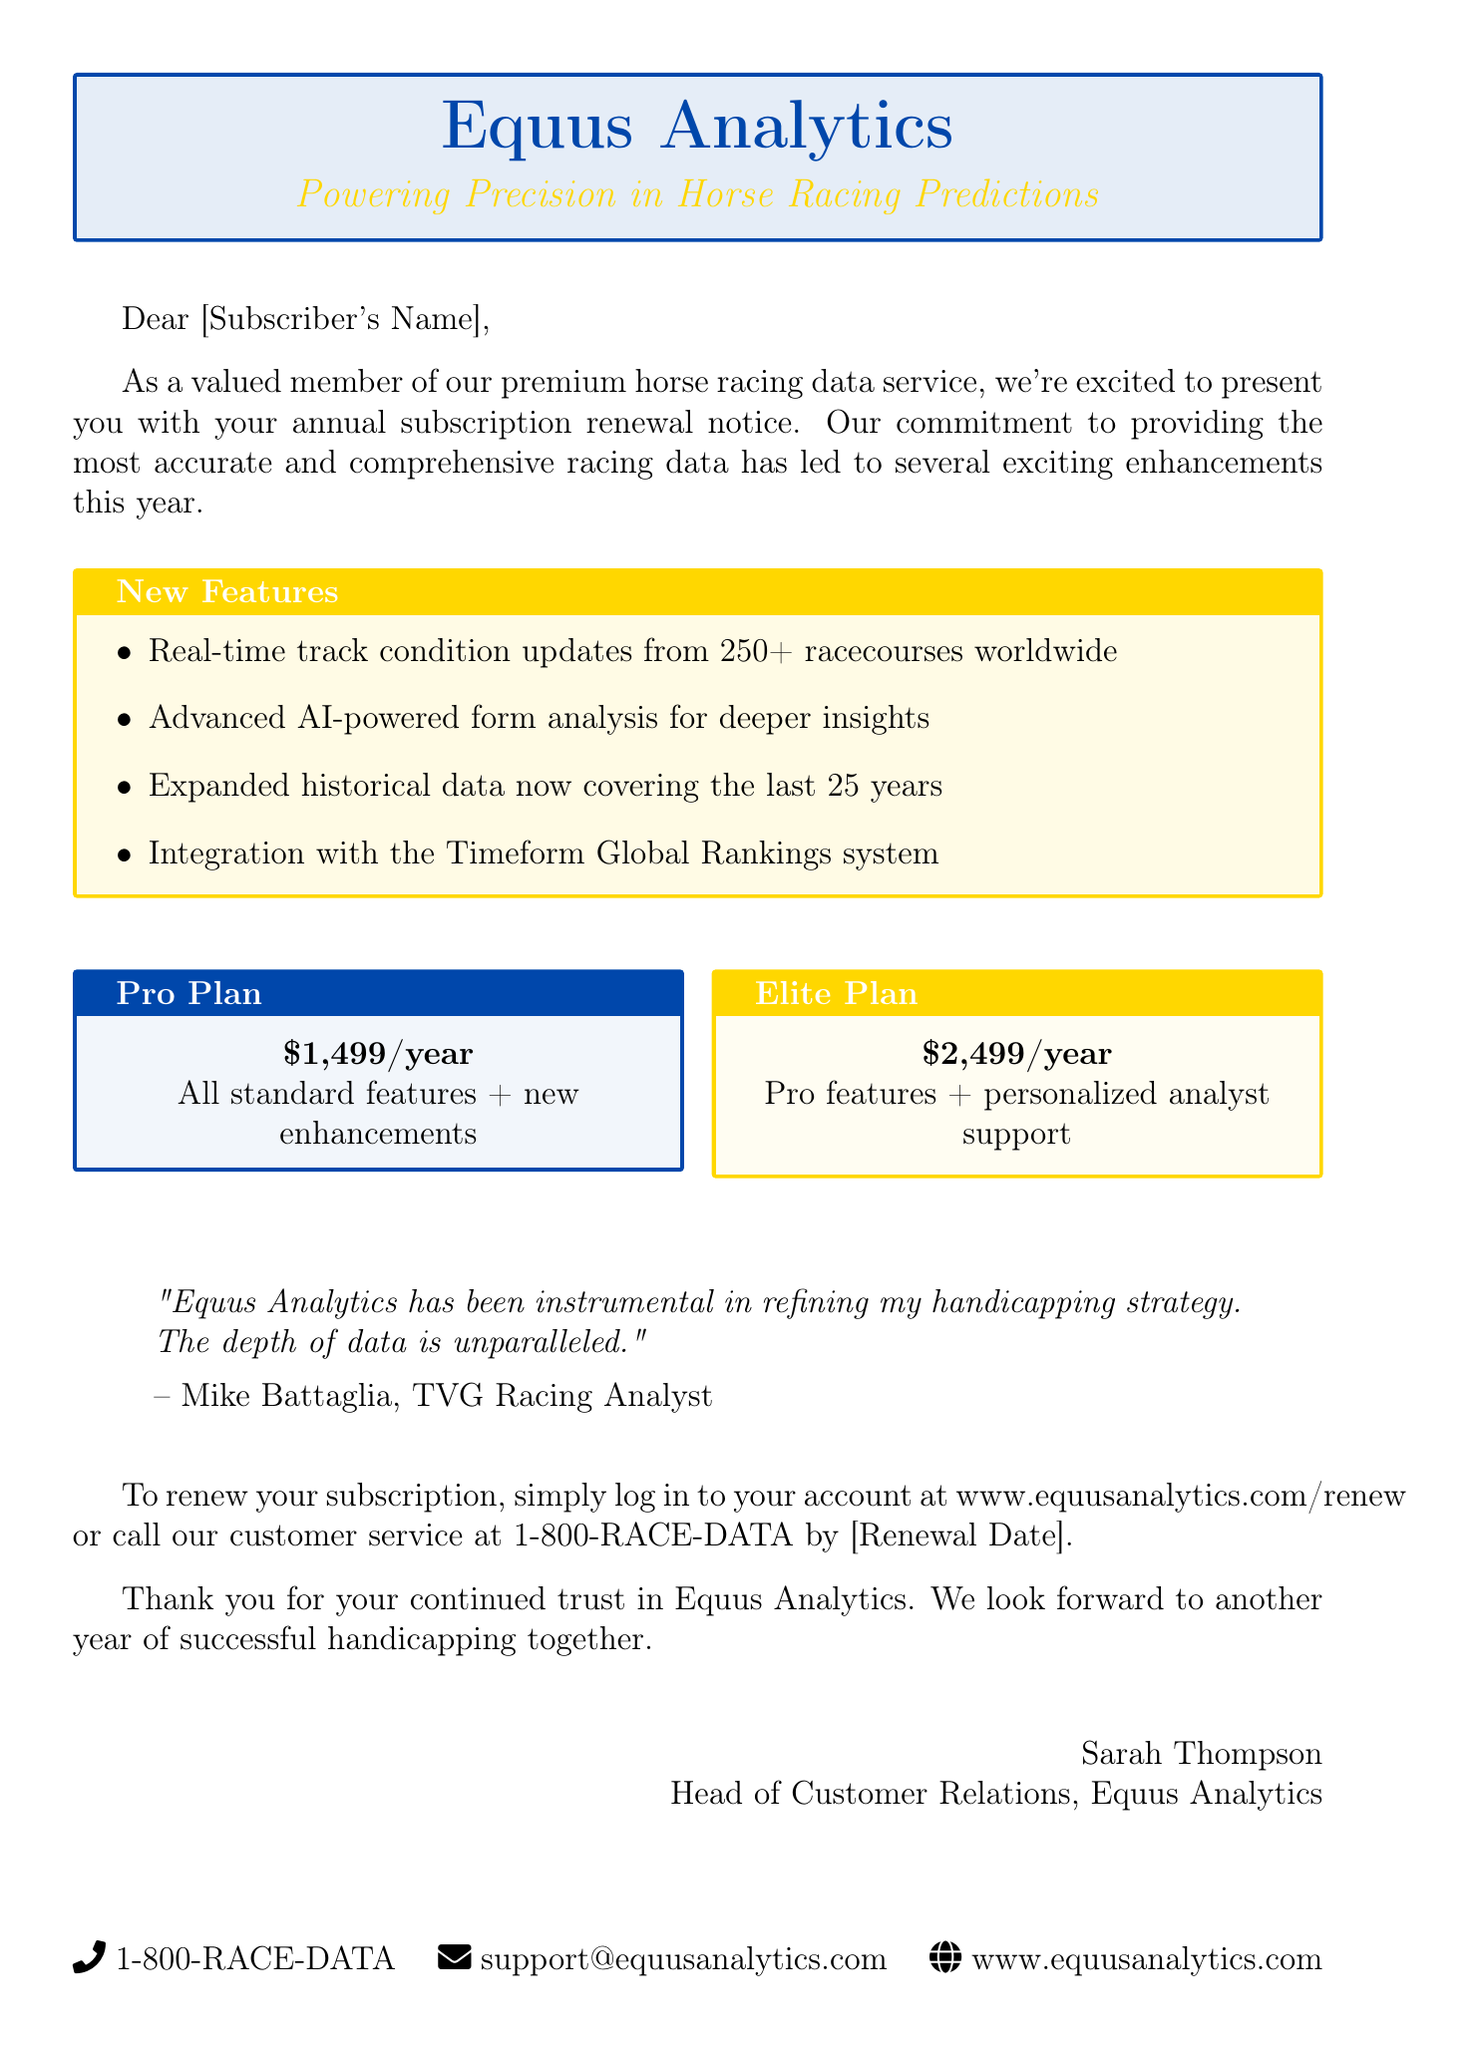What is the company name? The company name is presented prominently at the top of the document.
Answer: Equus Analytics What is the tagline of the company? The tagline is included directly under the company name.
Answer: Powering Precision in Horse Racing Predictions How many racecourses are included in the real-time track condition updates? The number of racecourses is specified in the list of new features.
Answer: 250+ What is the price of the Pro plan? The price of the Pro plan is mentioned in the pricing options section.
Answer: $1,499/year What additional support does the Elite plan offer? This detail is included in the description of the Elite plan.
Answer: Personalized analyst support Who is quoted in the testimonial? The author of the testimonial is indicated in the quote section of the document.
Answer: Mike Battaglia What is the renewal date mentioned in the instructions? The renewal date is suggested to be specified in the instructions section.
Answer: [Renewal Date] What should you do to renew your subscription? This action is described in the renewal instructions section.
Answer: Log in to your account or call customer service What are the features of the Elite plan? Features of the Elite plan are provided in the pricing options section.
Answer: Pro features + personalized analyst support 